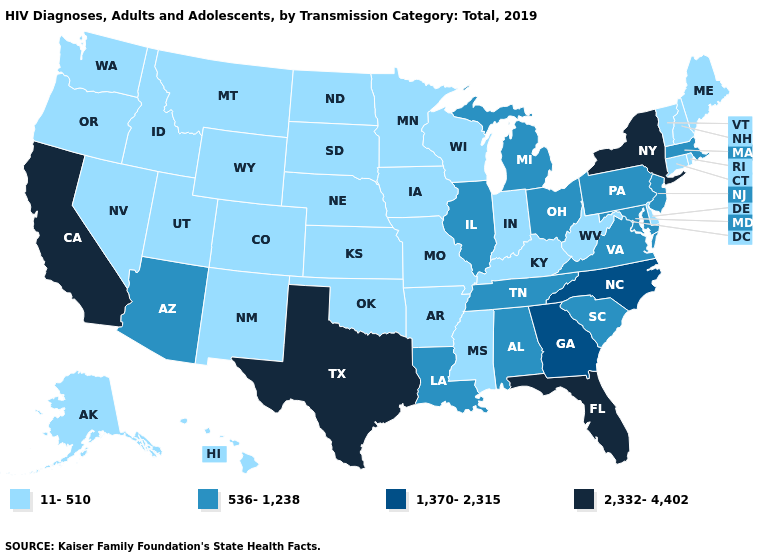What is the value of Arkansas?
Quick response, please. 11-510. Among the states that border Michigan , does Wisconsin have the lowest value?
Keep it brief. Yes. What is the value of Texas?
Keep it brief. 2,332-4,402. Which states have the highest value in the USA?
Be succinct. California, Florida, New York, Texas. What is the lowest value in the USA?
Quick response, please. 11-510. What is the highest value in the USA?
Short answer required. 2,332-4,402. What is the value of Kentucky?
Answer briefly. 11-510. Name the states that have a value in the range 2,332-4,402?
Concise answer only. California, Florida, New York, Texas. Does New Jersey have the lowest value in the USA?
Give a very brief answer. No. What is the value of Maryland?
Short answer required. 536-1,238. What is the lowest value in states that border Indiana?
Keep it brief. 11-510. Does New Hampshire have the same value as Rhode Island?
Quick response, please. Yes. What is the value of Texas?
Be succinct. 2,332-4,402. What is the highest value in the USA?
Keep it brief. 2,332-4,402. Name the states that have a value in the range 1,370-2,315?
Give a very brief answer. Georgia, North Carolina. 